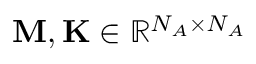Convert formula to latex. <formula><loc_0><loc_0><loc_500><loc_500>M , K \in \mathbb { R } ^ { N _ { A } \times N _ { A } }</formula> 